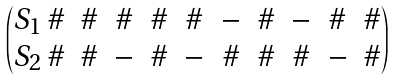Convert formula to latex. <formula><loc_0><loc_0><loc_500><loc_500>\begin{pmatrix} S _ { 1 } \, \# & \# & \# & \# & \# & - & \# & - & \# & \# \\ S _ { 2 } \, \# & \# & - & \# & - & \# & \# & \# & - & \# \end{pmatrix}</formula> 